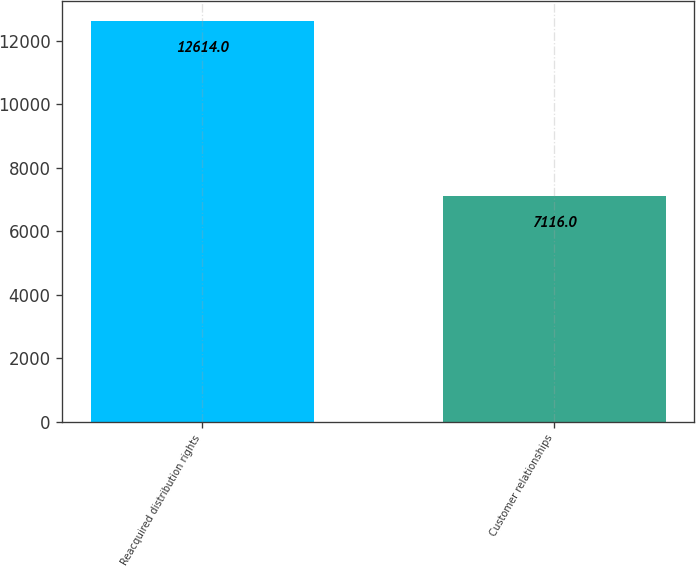Convert chart. <chart><loc_0><loc_0><loc_500><loc_500><bar_chart><fcel>Reacquired distribution rights<fcel>Customer relationships<nl><fcel>12614<fcel>7116<nl></chart> 